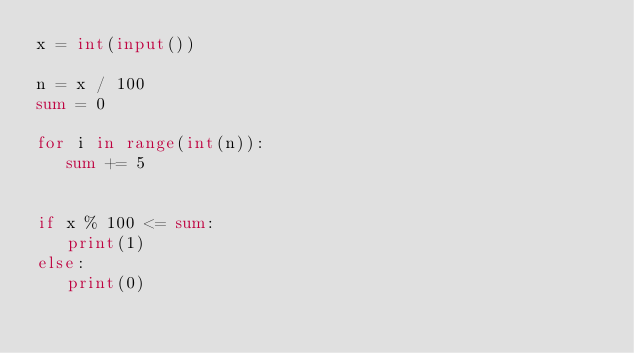<code> <loc_0><loc_0><loc_500><loc_500><_Python_>x = int(input())

n = x / 100
sum = 0

for i in range(int(n)):
   sum += 5


if x % 100 <= sum:
   print(1)
else:
   print(0)</code> 